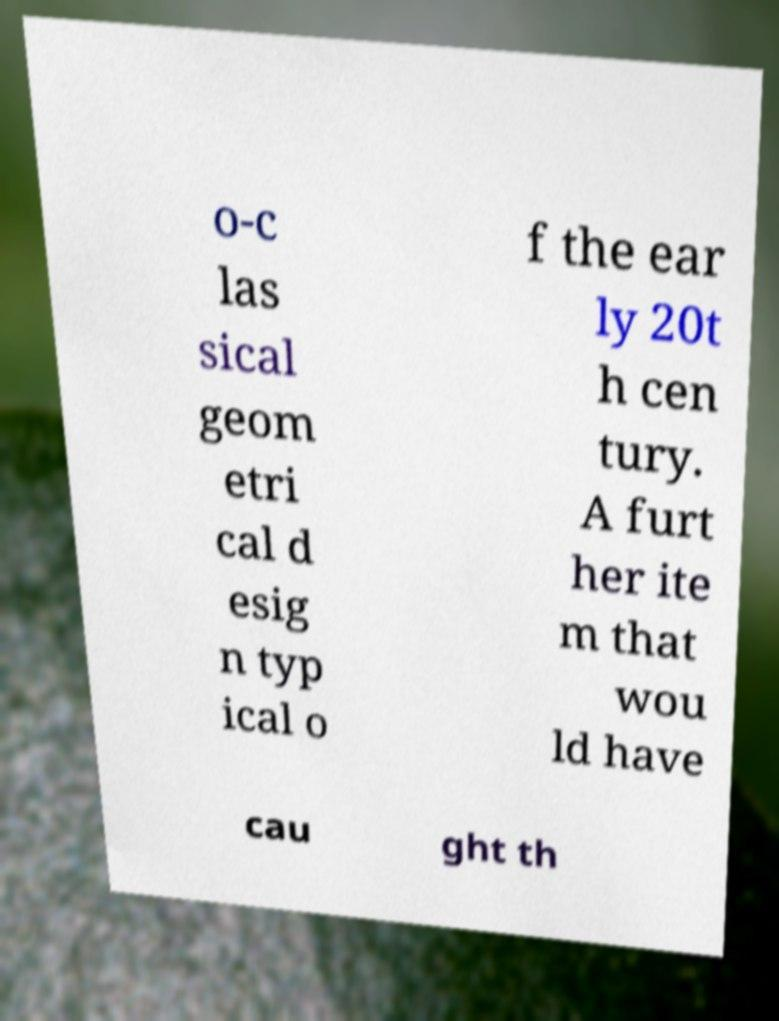For documentation purposes, I need the text within this image transcribed. Could you provide that? o-c las sical geom etri cal d esig n typ ical o f the ear ly 20t h cen tury. A furt her ite m that wou ld have cau ght th 